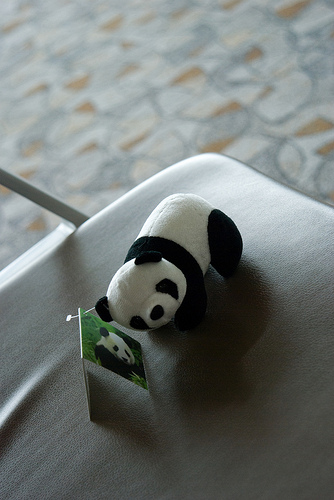<image>
Is there a panda above the chair? No. The panda is not positioned above the chair. The vertical arrangement shows a different relationship. 